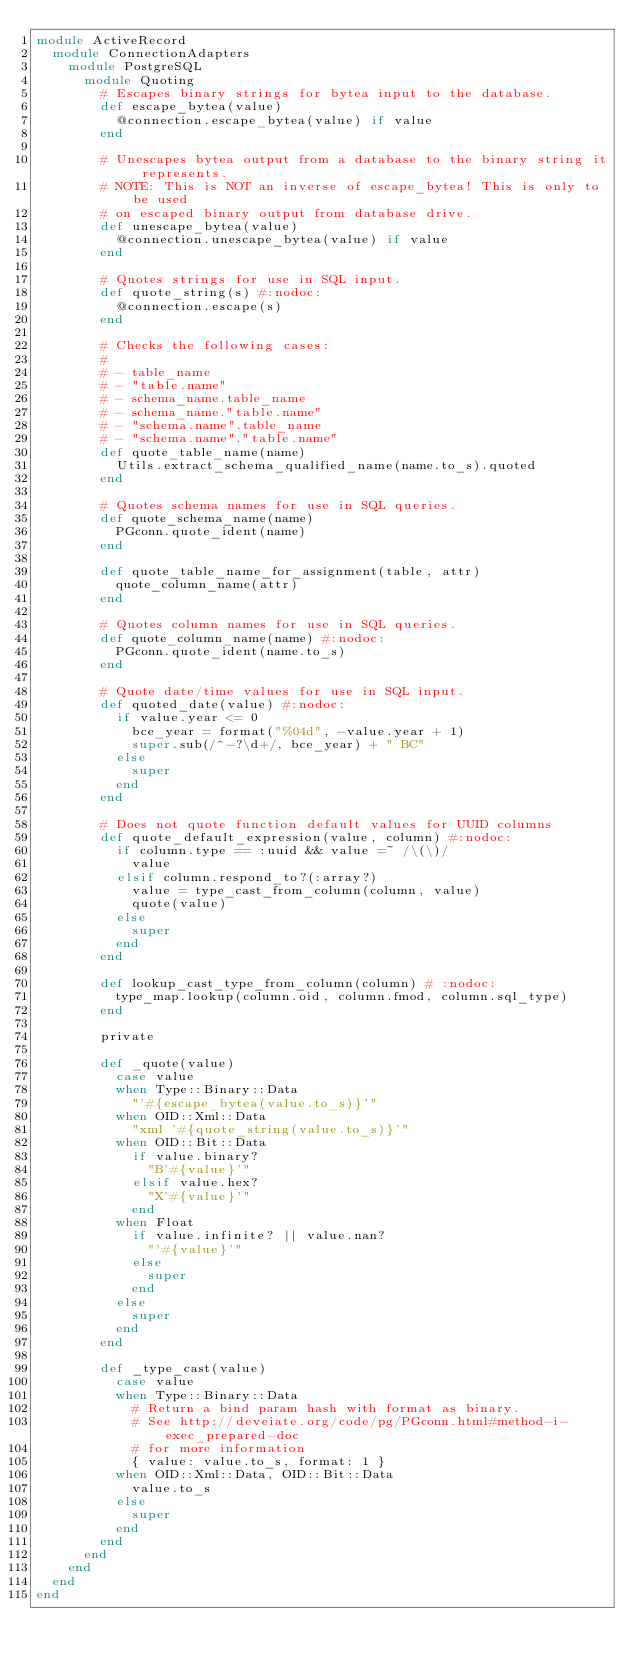<code> <loc_0><loc_0><loc_500><loc_500><_Ruby_>module ActiveRecord
  module ConnectionAdapters
    module PostgreSQL
      module Quoting
        # Escapes binary strings for bytea input to the database.
        def escape_bytea(value)
          @connection.escape_bytea(value) if value
        end

        # Unescapes bytea output from a database to the binary string it represents.
        # NOTE: This is NOT an inverse of escape_bytea! This is only to be used
        # on escaped binary output from database drive.
        def unescape_bytea(value)
          @connection.unescape_bytea(value) if value
        end

        # Quotes strings for use in SQL input.
        def quote_string(s) #:nodoc:
          @connection.escape(s)
        end

        # Checks the following cases:
        #
        # - table_name
        # - "table.name"
        # - schema_name.table_name
        # - schema_name."table.name"
        # - "schema.name".table_name
        # - "schema.name"."table.name"
        def quote_table_name(name)
          Utils.extract_schema_qualified_name(name.to_s).quoted
        end

        # Quotes schema names for use in SQL queries.
        def quote_schema_name(name)
          PGconn.quote_ident(name)
        end

        def quote_table_name_for_assignment(table, attr)
          quote_column_name(attr)
        end

        # Quotes column names for use in SQL queries.
        def quote_column_name(name) #:nodoc:
          PGconn.quote_ident(name.to_s)
        end

        # Quote date/time values for use in SQL input.
        def quoted_date(value) #:nodoc:
          if value.year <= 0
            bce_year = format("%04d", -value.year + 1)
            super.sub(/^-?\d+/, bce_year) + " BC"
          else
            super
          end
        end

        # Does not quote function default values for UUID columns
        def quote_default_expression(value, column) #:nodoc:
          if column.type == :uuid && value =~ /\(\)/
            value
          elsif column.respond_to?(:array?)
            value = type_cast_from_column(column, value)
            quote(value)
          else
            super
          end
        end

        def lookup_cast_type_from_column(column) # :nodoc:
          type_map.lookup(column.oid, column.fmod, column.sql_type)
        end

        private

        def _quote(value)
          case value
          when Type::Binary::Data
            "'#{escape_bytea(value.to_s)}'"
          when OID::Xml::Data
            "xml '#{quote_string(value.to_s)}'"
          when OID::Bit::Data
            if value.binary?
              "B'#{value}'"
            elsif value.hex?
              "X'#{value}'"
            end
          when Float
            if value.infinite? || value.nan?
              "'#{value}'"
            else
              super
            end
          else
            super
          end
        end

        def _type_cast(value)
          case value
          when Type::Binary::Data
            # Return a bind param hash with format as binary.
            # See http://deveiate.org/code/pg/PGconn.html#method-i-exec_prepared-doc
            # for more information
            { value: value.to_s, format: 1 }
          when OID::Xml::Data, OID::Bit::Data
            value.to_s
          else
            super
          end
        end
      end
    end
  end
end
</code> 